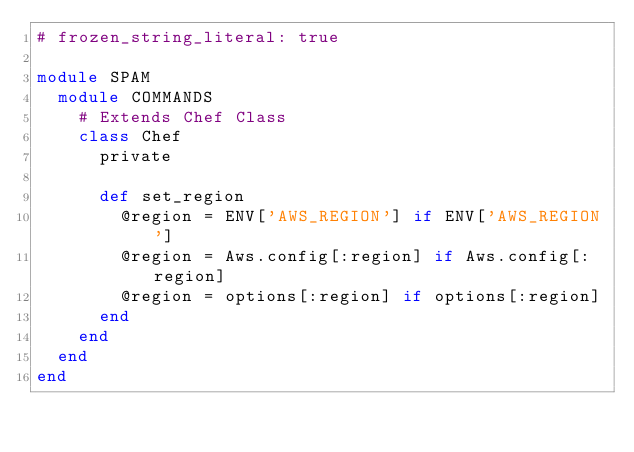<code> <loc_0><loc_0><loc_500><loc_500><_Ruby_># frozen_string_literal: true

module SPAM
  module COMMANDS
    # Extends Chef Class
    class Chef
      private

      def set_region
        @region = ENV['AWS_REGION'] if ENV['AWS_REGION']
        @region = Aws.config[:region] if Aws.config[:region]
        @region = options[:region] if options[:region]
      end
    end
  end
end
</code> 